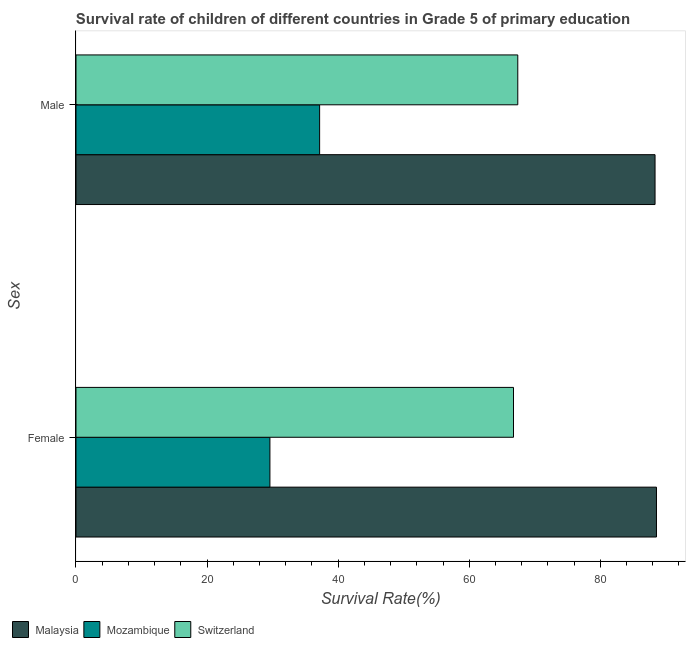How many bars are there on the 1st tick from the top?
Provide a short and direct response. 3. What is the label of the 2nd group of bars from the top?
Keep it short and to the point. Female. What is the survival rate of female students in primary education in Switzerland?
Provide a short and direct response. 66.75. Across all countries, what is the maximum survival rate of male students in primary education?
Make the answer very short. 88.35. Across all countries, what is the minimum survival rate of male students in primary education?
Make the answer very short. 37.17. In which country was the survival rate of male students in primary education maximum?
Provide a succinct answer. Malaysia. In which country was the survival rate of male students in primary education minimum?
Your response must be concise. Mozambique. What is the total survival rate of male students in primary education in the graph?
Offer a very short reply. 192.93. What is the difference between the survival rate of female students in primary education in Malaysia and that in Mozambique?
Ensure brevity in your answer.  58.98. What is the difference between the survival rate of female students in primary education in Switzerland and the survival rate of male students in primary education in Malaysia?
Make the answer very short. -21.6. What is the average survival rate of female students in primary education per country?
Provide a succinct answer. 61.64. What is the difference between the survival rate of female students in primary education and survival rate of male students in primary education in Switzerland?
Make the answer very short. -0.65. In how many countries, is the survival rate of male students in primary education greater than 20 %?
Offer a terse response. 3. What is the ratio of the survival rate of male students in primary education in Malaysia to that in Switzerland?
Make the answer very short. 1.31. Is the survival rate of female students in primary education in Malaysia less than that in Switzerland?
Provide a succinct answer. No. In how many countries, is the survival rate of female students in primary education greater than the average survival rate of female students in primary education taken over all countries?
Offer a terse response. 2. What does the 2nd bar from the top in Male represents?
Your answer should be compact. Mozambique. What does the 3rd bar from the bottom in Female represents?
Give a very brief answer. Switzerland. What is the difference between two consecutive major ticks on the X-axis?
Ensure brevity in your answer.  20. Does the graph contain any zero values?
Your answer should be compact. No. Does the graph contain grids?
Your response must be concise. No. How many legend labels are there?
Your answer should be very brief. 3. How are the legend labels stacked?
Provide a short and direct response. Horizontal. What is the title of the graph?
Your answer should be compact. Survival rate of children of different countries in Grade 5 of primary education. Does "Cabo Verde" appear as one of the legend labels in the graph?
Offer a terse response. No. What is the label or title of the X-axis?
Ensure brevity in your answer.  Survival Rate(%). What is the label or title of the Y-axis?
Offer a terse response. Sex. What is the Survival Rate(%) of Malaysia in Female?
Provide a short and direct response. 88.57. What is the Survival Rate(%) of Mozambique in Female?
Provide a short and direct response. 29.59. What is the Survival Rate(%) of Switzerland in Female?
Your response must be concise. 66.75. What is the Survival Rate(%) of Malaysia in Male?
Provide a succinct answer. 88.35. What is the Survival Rate(%) of Mozambique in Male?
Your answer should be compact. 37.17. What is the Survival Rate(%) in Switzerland in Male?
Your response must be concise. 67.41. Across all Sex, what is the maximum Survival Rate(%) of Malaysia?
Give a very brief answer. 88.57. Across all Sex, what is the maximum Survival Rate(%) in Mozambique?
Ensure brevity in your answer.  37.17. Across all Sex, what is the maximum Survival Rate(%) in Switzerland?
Offer a terse response. 67.41. Across all Sex, what is the minimum Survival Rate(%) of Malaysia?
Keep it short and to the point. 88.35. Across all Sex, what is the minimum Survival Rate(%) of Mozambique?
Offer a very short reply. 29.59. Across all Sex, what is the minimum Survival Rate(%) of Switzerland?
Provide a succinct answer. 66.75. What is the total Survival Rate(%) in Malaysia in the graph?
Make the answer very short. 176.92. What is the total Survival Rate(%) in Mozambique in the graph?
Make the answer very short. 66.76. What is the total Survival Rate(%) of Switzerland in the graph?
Offer a terse response. 134.16. What is the difference between the Survival Rate(%) in Malaysia in Female and that in Male?
Your answer should be compact. 0.22. What is the difference between the Survival Rate(%) of Mozambique in Female and that in Male?
Offer a very short reply. -7.58. What is the difference between the Survival Rate(%) of Switzerland in Female and that in Male?
Offer a very short reply. -0.65. What is the difference between the Survival Rate(%) in Malaysia in Female and the Survival Rate(%) in Mozambique in Male?
Keep it short and to the point. 51.39. What is the difference between the Survival Rate(%) in Malaysia in Female and the Survival Rate(%) in Switzerland in Male?
Offer a very short reply. 21.16. What is the difference between the Survival Rate(%) of Mozambique in Female and the Survival Rate(%) of Switzerland in Male?
Your answer should be very brief. -37.82. What is the average Survival Rate(%) in Malaysia per Sex?
Give a very brief answer. 88.46. What is the average Survival Rate(%) in Mozambique per Sex?
Ensure brevity in your answer.  33.38. What is the average Survival Rate(%) of Switzerland per Sex?
Provide a short and direct response. 67.08. What is the difference between the Survival Rate(%) of Malaysia and Survival Rate(%) of Mozambique in Female?
Your response must be concise. 58.98. What is the difference between the Survival Rate(%) in Malaysia and Survival Rate(%) in Switzerland in Female?
Give a very brief answer. 21.81. What is the difference between the Survival Rate(%) in Mozambique and Survival Rate(%) in Switzerland in Female?
Offer a terse response. -37.16. What is the difference between the Survival Rate(%) of Malaysia and Survival Rate(%) of Mozambique in Male?
Keep it short and to the point. 51.18. What is the difference between the Survival Rate(%) in Malaysia and Survival Rate(%) in Switzerland in Male?
Your response must be concise. 20.94. What is the difference between the Survival Rate(%) of Mozambique and Survival Rate(%) of Switzerland in Male?
Make the answer very short. -30.23. What is the ratio of the Survival Rate(%) in Mozambique in Female to that in Male?
Provide a short and direct response. 0.8. What is the ratio of the Survival Rate(%) of Switzerland in Female to that in Male?
Make the answer very short. 0.99. What is the difference between the highest and the second highest Survival Rate(%) in Malaysia?
Provide a short and direct response. 0.22. What is the difference between the highest and the second highest Survival Rate(%) of Mozambique?
Ensure brevity in your answer.  7.58. What is the difference between the highest and the second highest Survival Rate(%) in Switzerland?
Your response must be concise. 0.65. What is the difference between the highest and the lowest Survival Rate(%) of Malaysia?
Keep it short and to the point. 0.22. What is the difference between the highest and the lowest Survival Rate(%) in Mozambique?
Provide a short and direct response. 7.58. What is the difference between the highest and the lowest Survival Rate(%) of Switzerland?
Your response must be concise. 0.65. 